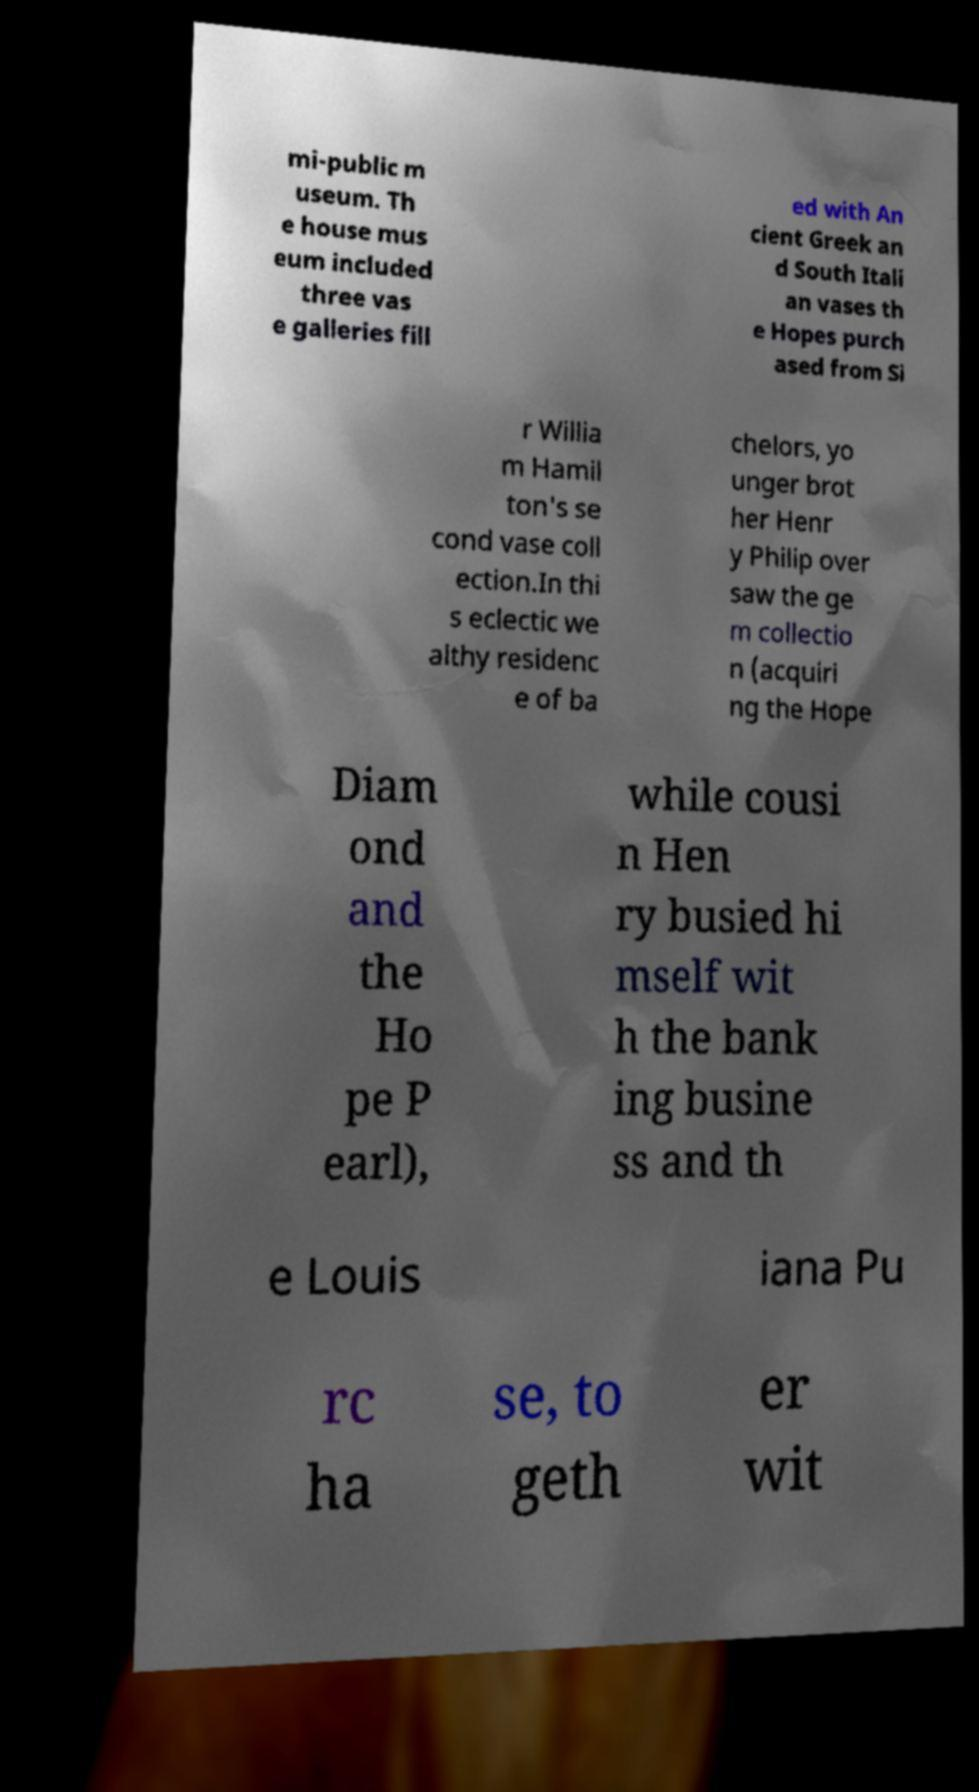For documentation purposes, I need the text within this image transcribed. Could you provide that? mi-public m useum. Th e house mus eum included three vas e galleries fill ed with An cient Greek an d South Itali an vases th e Hopes purch ased from Si r Willia m Hamil ton's se cond vase coll ection.In thi s eclectic we althy residenc e of ba chelors, yo unger brot her Henr y Philip over saw the ge m collectio n (acquiri ng the Hope Diam ond and the Ho pe P earl), while cousi n Hen ry busied hi mself wit h the bank ing busine ss and th e Louis iana Pu rc ha se, to geth er wit 